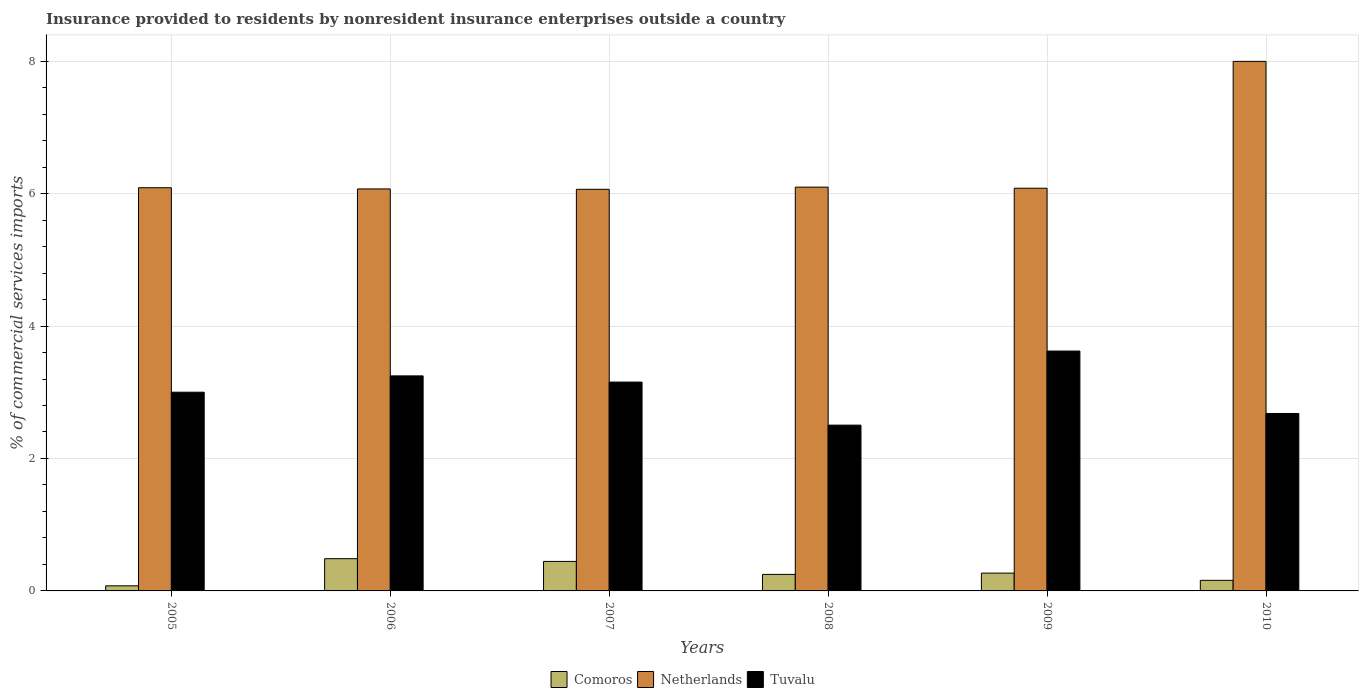How many different coloured bars are there?
Give a very brief answer. 3. Are the number of bars on each tick of the X-axis equal?
Ensure brevity in your answer.  Yes. How many bars are there on the 2nd tick from the right?
Provide a short and direct response. 3. What is the Insurance provided to residents in Netherlands in 2008?
Provide a succinct answer. 6.1. Across all years, what is the maximum Insurance provided to residents in Tuvalu?
Your answer should be very brief. 3.62. Across all years, what is the minimum Insurance provided to residents in Comoros?
Your answer should be very brief. 0.08. In which year was the Insurance provided to residents in Tuvalu maximum?
Make the answer very short. 2009. What is the total Insurance provided to residents in Comoros in the graph?
Keep it short and to the point. 1.69. What is the difference between the Insurance provided to residents in Tuvalu in 2006 and that in 2007?
Offer a very short reply. 0.09. What is the difference between the Insurance provided to residents in Netherlands in 2009 and the Insurance provided to residents in Tuvalu in 2006?
Your answer should be very brief. 2.83. What is the average Insurance provided to residents in Comoros per year?
Give a very brief answer. 0.28. In the year 2008, what is the difference between the Insurance provided to residents in Tuvalu and Insurance provided to residents in Comoros?
Make the answer very short. 2.25. In how many years, is the Insurance provided to residents in Tuvalu greater than 3.6 %?
Give a very brief answer. 1. What is the ratio of the Insurance provided to residents in Tuvalu in 2006 to that in 2009?
Your answer should be very brief. 0.9. Is the difference between the Insurance provided to residents in Tuvalu in 2009 and 2010 greater than the difference between the Insurance provided to residents in Comoros in 2009 and 2010?
Keep it short and to the point. Yes. What is the difference between the highest and the second highest Insurance provided to residents in Comoros?
Offer a terse response. 0.04. What is the difference between the highest and the lowest Insurance provided to residents in Comoros?
Offer a terse response. 0.41. In how many years, is the Insurance provided to residents in Tuvalu greater than the average Insurance provided to residents in Tuvalu taken over all years?
Give a very brief answer. 3. What does the 3rd bar from the left in 2007 represents?
Provide a succinct answer. Tuvalu. Is it the case that in every year, the sum of the Insurance provided to residents in Netherlands and Insurance provided to residents in Tuvalu is greater than the Insurance provided to residents in Comoros?
Your answer should be very brief. Yes. How many bars are there?
Make the answer very short. 18. How many years are there in the graph?
Give a very brief answer. 6. Are the values on the major ticks of Y-axis written in scientific E-notation?
Provide a short and direct response. No. Does the graph contain any zero values?
Your response must be concise. No. Does the graph contain grids?
Offer a terse response. Yes. What is the title of the graph?
Give a very brief answer. Insurance provided to residents by nonresident insurance enterprises outside a country. Does "Costa Rica" appear as one of the legend labels in the graph?
Offer a very short reply. No. What is the label or title of the Y-axis?
Provide a succinct answer. % of commercial services imports. What is the % of commercial services imports in Comoros in 2005?
Offer a very short reply. 0.08. What is the % of commercial services imports of Netherlands in 2005?
Ensure brevity in your answer.  6.09. What is the % of commercial services imports of Tuvalu in 2005?
Offer a very short reply. 3. What is the % of commercial services imports in Comoros in 2006?
Make the answer very short. 0.49. What is the % of commercial services imports of Netherlands in 2006?
Offer a terse response. 6.07. What is the % of commercial services imports in Tuvalu in 2006?
Your answer should be compact. 3.25. What is the % of commercial services imports in Comoros in 2007?
Offer a terse response. 0.45. What is the % of commercial services imports in Netherlands in 2007?
Your answer should be compact. 6.06. What is the % of commercial services imports in Tuvalu in 2007?
Make the answer very short. 3.15. What is the % of commercial services imports of Comoros in 2008?
Your answer should be compact. 0.25. What is the % of commercial services imports in Netherlands in 2008?
Your response must be concise. 6.1. What is the % of commercial services imports of Tuvalu in 2008?
Ensure brevity in your answer.  2.5. What is the % of commercial services imports in Comoros in 2009?
Provide a succinct answer. 0.27. What is the % of commercial services imports of Netherlands in 2009?
Keep it short and to the point. 6.08. What is the % of commercial services imports in Tuvalu in 2009?
Provide a short and direct response. 3.62. What is the % of commercial services imports of Comoros in 2010?
Your response must be concise. 0.16. What is the % of commercial services imports of Netherlands in 2010?
Make the answer very short. 8. What is the % of commercial services imports of Tuvalu in 2010?
Give a very brief answer. 2.68. Across all years, what is the maximum % of commercial services imports in Comoros?
Your response must be concise. 0.49. Across all years, what is the maximum % of commercial services imports of Netherlands?
Provide a short and direct response. 8. Across all years, what is the maximum % of commercial services imports in Tuvalu?
Make the answer very short. 3.62. Across all years, what is the minimum % of commercial services imports in Comoros?
Offer a terse response. 0.08. Across all years, what is the minimum % of commercial services imports in Netherlands?
Your answer should be compact. 6.06. Across all years, what is the minimum % of commercial services imports of Tuvalu?
Ensure brevity in your answer.  2.5. What is the total % of commercial services imports in Comoros in the graph?
Provide a short and direct response. 1.69. What is the total % of commercial services imports in Netherlands in the graph?
Keep it short and to the point. 38.4. What is the total % of commercial services imports of Tuvalu in the graph?
Make the answer very short. 18.21. What is the difference between the % of commercial services imports of Comoros in 2005 and that in 2006?
Ensure brevity in your answer.  -0.41. What is the difference between the % of commercial services imports in Netherlands in 2005 and that in 2006?
Offer a very short reply. 0.02. What is the difference between the % of commercial services imports in Tuvalu in 2005 and that in 2006?
Provide a short and direct response. -0.25. What is the difference between the % of commercial services imports of Comoros in 2005 and that in 2007?
Your response must be concise. -0.37. What is the difference between the % of commercial services imports in Netherlands in 2005 and that in 2007?
Give a very brief answer. 0.02. What is the difference between the % of commercial services imports of Tuvalu in 2005 and that in 2007?
Provide a short and direct response. -0.15. What is the difference between the % of commercial services imports in Comoros in 2005 and that in 2008?
Give a very brief answer. -0.17. What is the difference between the % of commercial services imports of Netherlands in 2005 and that in 2008?
Offer a very short reply. -0.01. What is the difference between the % of commercial services imports of Tuvalu in 2005 and that in 2008?
Provide a succinct answer. 0.5. What is the difference between the % of commercial services imports in Comoros in 2005 and that in 2009?
Provide a short and direct response. -0.19. What is the difference between the % of commercial services imports of Netherlands in 2005 and that in 2009?
Provide a succinct answer. 0.01. What is the difference between the % of commercial services imports in Tuvalu in 2005 and that in 2009?
Ensure brevity in your answer.  -0.62. What is the difference between the % of commercial services imports of Comoros in 2005 and that in 2010?
Make the answer very short. -0.08. What is the difference between the % of commercial services imports in Netherlands in 2005 and that in 2010?
Your answer should be compact. -1.91. What is the difference between the % of commercial services imports of Tuvalu in 2005 and that in 2010?
Provide a succinct answer. 0.32. What is the difference between the % of commercial services imports in Comoros in 2006 and that in 2007?
Your response must be concise. 0.04. What is the difference between the % of commercial services imports of Netherlands in 2006 and that in 2007?
Give a very brief answer. 0.01. What is the difference between the % of commercial services imports in Tuvalu in 2006 and that in 2007?
Provide a short and direct response. 0.09. What is the difference between the % of commercial services imports of Comoros in 2006 and that in 2008?
Your answer should be very brief. 0.24. What is the difference between the % of commercial services imports of Netherlands in 2006 and that in 2008?
Provide a short and direct response. -0.03. What is the difference between the % of commercial services imports in Tuvalu in 2006 and that in 2008?
Your response must be concise. 0.74. What is the difference between the % of commercial services imports in Comoros in 2006 and that in 2009?
Make the answer very short. 0.22. What is the difference between the % of commercial services imports of Netherlands in 2006 and that in 2009?
Ensure brevity in your answer.  -0.01. What is the difference between the % of commercial services imports in Tuvalu in 2006 and that in 2009?
Ensure brevity in your answer.  -0.38. What is the difference between the % of commercial services imports in Comoros in 2006 and that in 2010?
Provide a succinct answer. 0.33. What is the difference between the % of commercial services imports of Netherlands in 2006 and that in 2010?
Ensure brevity in your answer.  -1.93. What is the difference between the % of commercial services imports of Tuvalu in 2006 and that in 2010?
Your answer should be very brief. 0.57. What is the difference between the % of commercial services imports in Comoros in 2007 and that in 2008?
Provide a short and direct response. 0.2. What is the difference between the % of commercial services imports of Netherlands in 2007 and that in 2008?
Your response must be concise. -0.03. What is the difference between the % of commercial services imports in Tuvalu in 2007 and that in 2008?
Provide a succinct answer. 0.65. What is the difference between the % of commercial services imports in Comoros in 2007 and that in 2009?
Your answer should be compact. 0.18. What is the difference between the % of commercial services imports of Netherlands in 2007 and that in 2009?
Provide a short and direct response. -0.02. What is the difference between the % of commercial services imports in Tuvalu in 2007 and that in 2009?
Ensure brevity in your answer.  -0.47. What is the difference between the % of commercial services imports of Comoros in 2007 and that in 2010?
Make the answer very short. 0.29. What is the difference between the % of commercial services imports in Netherlands in 2007 and that in 2010?
Your response must be concise. -1.93. What is the difference between the % of commercial services imports of Tuvalu in 2007 and that in 2010?
Provide a short and direct response. 0.47. What is the difference between the % of commercial services imports in Comoros in 2008 and that in 2009?
Your answer should be very brief. -0.02. What is the difference between the % of commercial services imports in Netherlands in 2008 and that in 2009?
Keep it short and to the point. 0.02. What is the difference between the % of commercial services imports in Tuvalu in 2008 and that in 2009?
Ensure brevity in your answer.  -1.12. What is the difference between the % of commercial services imports in Comoros in 2008 and that in 2010?
Make the answer very short. 0.09. What is the difference between the % of commercial services imports of Netherlands in 2008 and that in 2010?
Keep it short and to the point. -1.9. What is the difference between the % of commercial services imports in Tuvalu in 2008 and that in 2010?
Keep it short and to the point. -0.18. What is the difference between the % of commercial services imports in Comoros in 2009 and that in 2010?
Offer a terse response. 0.11. What is the difference between the % of commercial services imports of Netherlands in 2009 and that in 2010?
Provide a short and direct response. -1.92. What is the difference between the % of commercial services imports of Tuvalu in 2009 and that in 2010?
Give a very brief answer. 0.94. What is the difference between the % of commercial services imports of Comoros in 2005 and the % of commercial services imports of Netherlands in 2006?
Ensure brevity in your answer.  -5.99. What is the difference between the % of commercial services imports of Comoros in 2005 and the % of commercial services imports of Tuvalu in 2006?
Offer a very short reply. -3.17. What is the difference between the % of commercial services imports of Netherlands in 2005 and the % of commercial services imports of Tuvalu in 2006?
Keep it short and to the point. 2.84. What is the difference between the % of commercial services imports in Comoros in 2005 and the % of commercial services imports in Netherlands in 2007?
Give a very brief answer. -5.99. What is the difference between the % of commercial services imports in Comoros in 2005 and the % of commercial services imports in Tuvalu in 2007?
Provide a short and direct response. -3.08. What is the difference between the % of commercial services imports of Netherlands in 2005 and the % of commercial services imports of Tuvalu in 2007?
Offer a very short reply. 2.93. What is the difference between the % of commercial services imports of Comoros in 2005 and the % of commercial services imports of Netherlands in 2008?
Provide a succinct answer. -6.02. What is the difference between the % of commercial services imports of Comoros in 2005 and the % of commercial services imports of Tuvalu in 2008?
Your answer should be very brief. -2.43. What is the difference between the % of commercial services imports of Netherlands in 2005 and the % of commercial services imports of Tuvalu in 2008?
Provide a short and direct response. 3.59. What is the difference between the % of commercial services imports of Comoros in 2005 and the % of commercial services imports of Netherlands in 2009?
Ensure brevity in your answer.  -6. What is the difference between the % of commercial services imports of Comoros in 2005 and the % of commercial services imports of Tuvalu in 2009?
Offer a terse response. -3.55. What is the difference between the % of commercial services imports of Netherlands in 2005 and the % of commercial services imports of Tuvalu in 2009?
Your response must be concise. 2.47. What is the difference between the % of commercial services imports of Comoros in 2005 and the % of commercial services imports of Netherlands in 2010?
Provide a short and direct response. -7.92. What is the difference between the % of commercial services imports in Comoros in 2005 and the % of commercial services imports in Tuvalu in 2010?
Your response must be concise. -2.6. What is the difference between the % of commercial services imports of Netherlands in 2005 and the % of commercial services imports of Tuvalu in 2010?
Provide a short and direct response. 3.41. What is the difference between the % of commercial services imports of Comoros in 2006 and the % of commercial services imports of Netherlands in 2007?
Offer a very short reply. -5.58. What is the difference between the % of commercial services imports in Comoros in 2006 and the % of commercial services imports in Tuvalu in 2007?
Provide a short and direct response. -2.67. What is the difference between the % of commercial services imports of Netherlands in 2006 and the % of commercial services imports of Tuvalu in 2007?
Keep it short and to the point. 2.92. What is the difference between the % of commercial services imports of Comoros in 2006 and the % of commercial services imports of Netherlands in 2008?
Ensure brevity in your answer.  -5.61. What is the difference between the % of commercial services imports of Comoros in 2006 and the % of commercial services imports of Tuvalu in 2008?
Your answer should be very brief. -2.02. What is the difference between the % of commercial services imports in Netherlands in 2006 and the % of commercial services imports in Tuvalu in 2008?
Give a very brief answer. 3.57. What is the difference between the % of commercial services imports of Comoros in 2006 and the % of commercial services imports of Netherlands in 2009?
Make the answer very short. -5.59. What is the difference between the % of commercial services imports of Comoros in 2006 and the % of commercial services imports of Tuvalu in 2009?
Give a very brief answer. -3.14. What is the difference between the % of commercial services imports in Netherlands in 2006 and the % of commercial services imports in Tuvalu in 2009?
Your answer should be very brief. 2.45. What is the difference between the % of commercial services imports in Comoros in 2006 and the % of commercial services imports in Netherlands in 2010?
Make the answer very short. -7.51. What is the difference between the % of commercial services imports in Comoros in 2006 and the % of commercial services imports in Tuvalu in 2010?
Keep it short and to the point. -2.19. What is the difference between the % of commercial services imports in Netherlands in 2006 and the % of commercial services imports in Tuvalu in 2010?
Your answer should be compact. 3.39. What is the difference between the % of commercial services imports in Comoros in 2007 and the % of commercial services imports in Netherlands in 2008?
Offer a terse response. -5.65. What is the difference between the % of commercial services imports in Comoros in 2007 and the % of commercial services imports in Tuvalu in 2008?
Ensure brevity in your answer.  -2.06. What is the difference between the % of commercial services imports of Netherlands in 2007 and the % of commercial services imports of Tuvalu in 2008?
Keep it short and to the point. 3.56. What is the difference between the % of commercial services imports of Comoros in 2007 and the % of commercial services imports of Netherlands in 2009?
Make the answer very short. -5.64. What is the difference between the % of commercial services imports in Comoros in 2007 and the % of commercial services imports in Tuvalu in 2009?
Provide a short and direct response. -3.18. What is the difference between the % of commercial services imports of Netherlands in 2007 and the % of commercial services imports of Tuvalu in 2009?
Provide a short and direct response. 2.44. What is the difference between the % of commercial services imports in Comoros in 2007 and the % of commercial services imports in Netherlands in 2010?
Your response must be concise. -7.55. What is the difference between the % of commercial services imports in Comoros in 2007 and the % of commercial services imports in Tuvalu in 2010?
Offer a terse response. -2.23. What is the difference between the % of commercial services imports of Netherlands in 2007 and the % of commercial services imports of Tuvalu in 2010?
Keep it short and to the point. 3.39. What is the difference between the % of commercial services imports in Comoros in 2008 and the % of commercial services imports in Netherlands in 2009?
Provide a short and direct response. -5.83. What is the difference between the % of commercial services imports of Comoros in 2008 and the % of commercial services imports of Tuvalu in 2009?
Ensure brevity in your answer.  -3.37. What is the difference between the % of commercial services imports of Netherlands in 2008 and the % of commercial services imports of Tuvalu in 2009?
Keep it short and to the point. 2.48. What is the difference between the % of commercial services imports of Comoros in 2008 and the % of commercial services imports of Netherlands in 2010?
Offer a terse response. -7.75. What is the difference between the % of commercial services imports in Comoros in 2008 and the % of commercial services imports in Tuvalu in 2010?
Your answer should be very brief. -2.43. What is the difference between the % of commercial services imports in Netherlands in 2008 and the % of commercial services imports in Tuvalu in 2010?
Offer a terse response. 3.42. What is the difference between the % of commercial services imports of Comoros in 2009 and the % of commercial services imports of Netherlands in 2010?
Offer a very short reply. -7.73. What is the difference between the % of commercial services imports of Comoros in 2009 and the % of commercial services imports of Tuvalu in 2010?
Your answer should be very brief. -2.41. What is the difference between the % of commercial services imports of Netherlands in 2009 and the % of commercial services imports of Tuvalu in 2010?
Your response must be concise. 3.4. What is the average % of commercial services imports of Comoros per year?
Your answer should be very brief. 0.28. What is the average % of commercial services imports in Netherlands per year?
Make the answer very short. 6.4. What is the average % of commercial services imports of Tuvalu per year?
Keep it short and to the point. 3.03. In the year 2005, what is the difference between the % of commercial services imports of Comoros and % of commercial services imports of Netherlands?
Your answer should be very brief. -6.01. In the year 2005, what is the difference between the % of commercial services imports of Comoros and % of commercial services imports of Tuvalu?
Your answer should be compact. -2.92. In the year 2005, what is the difference between the % of commercial services imports of Netherlands and % of commercial services imports of Tuvalu?
Keep it short and to the point. 3.09. In the year 2006, what is the difference between the % of commercial services imports in Comoros and % of commercial services imports in Netherlands?
Keep it short and to the point. -5.58. In the year 2006, what is the difference between the % of commercial services imports of Comoros and % of commercial services imports of Tuvalu?
Make the answer very short. -2.76. In the year 2006, what is the difference between the % of commercial services imports in Netherlands and % of commercial services imports in Tuvalu?
Make the answer very short. 2.82. In the year 2007, what is the difference between the % of commercial services imports in Comoros and % of commercial services imports in Netherlands?
Make the answer very short. -5.62. In the year 2007, what is the difference between the % of commercial services imports of Comoros and % of commercial services imports of Tuvalu?
Offer a terse response. -2.71. In the year 2007, what is the difference between the % of commercial services imports in Netherlands and % of commercial services imports in Tuvalu?
Your response must be concise. 2.91. In the year 2008, what is the difference between the % of commercial services imports in Comoros and % of commercial services imports in Netherlands?
Your answer should be compact. -5.85. In the year 2008, what is the difference between the % of commercial services imports in Comoros and % of commercial services imports in Tuvalu?
Your answer should be compact. -2.25. In the year 2008, what is the difference between the % of commercial services imports of Netherlands and % of commercial services imports of Tuvalu?
Provide a short and direct response. 3.59. In the year 2009, what is the difference between the % of commercial services imports in Comoros and % of commercial services imports in Netherlands?
Make the answer very short. -5.81. In the year 2009, what is the difference between the % of commercial services imports in Comoros and % of commercial services imports in Tuvalu?
Ensure brevity in your answer.  -3.35. In the year 2009, what is the difference between the % of commercial services imports in Netherlands and % of commercial services imports in Tuvalu?
Offer a terse response. 2.46. In the year 2010, what is the difference between the % of commercial services imports in Comoros and % of commercial services imports in Netherlands?
Your answer should be compact. -7.84. In the year 2010, what is the difference between the % of commercial services imports of Comoros and % of commercial services imports of Tuvalu?
Ensure brevity in your answer.  -2.52. In the year 2010, what is the difference between the % of commercial services imports in Netherlands and % of commercial services imports in Tuvalu?
Provide a short and direct response. 5.32. What is the ratio of the % of commercial services imports of Comoros in 2005 to that in 2006?
Your answer should be very brief. 0.16. What is the ratio of the % of commercial services imports in Netherlands in 2005 to that in 2006?
Make the answer very short. 1. What is the ratio of the % of commercial services imports in Tuvalu in 2005 to that in 2006?
Make the answer very short. 0.92. What is the ratio of the % of commercial services imports in Comoros in 2005 to that in 2007?
Your response must be concise. 0.17. What is the ratio of the % of commercial services imports of Tuvalu in 2005 to that in 2007?
Give a very brief answer. 0.95. What is the ratio of the % of commercial services imports in Comoros in 2005 to that in 2008?
Your answer should be very brief. 0.31. What is the ratio of the % of commercial services imports of Netherlands in 2005 to that in 2008?
Offer a terse response. 1. What is the ratio of the % of commercial services imports in Tuvalu in 2005 to that in 2008?
Provide a succinct answer. 1.2. What is the ratio of the % of commercial services imports of Comoros in 2005 to that in 2009?
Your response must be concise. 0.29. What is the ratio of the % of commercial services imports in Tuvalu in 2005 to that in 2009?
Ensure brevity in your answer.  0.83. What is the ratio of the % of commercial services imports in Comoros in 2005 to that in 2010?
Provide a succinct answer. 0.48. What is the ratio of the % of commercial services imports of Netherlands in 2005 to that in 2010?
Offer a very short reply. 0.76. What is the ratio of the % of commercial services imports of Tuvalu in 2005 to that in 2010?
Your answer should be very brief. 1.12. What is the ratio of the % of commercial services imports of Comoros in 2006 to that in 2007?
Ensure brevity in your answer.  1.09. What is the ratio of the % of commercial services imports in Tuvalu in 2006 to that in 2007?
Keep it short and to the point. 1.03. What is the ratio of the % of commercial services imports in Comoros in 2006 to that in 2008?
Your response must be concise. 1.95. What is the ratio of the % of commercial services imports of Netherlands in 2006 to that in 2008?
Your response must be concise. 1. What is the ratio of the % of commercial services imports of Tuvalu in 2006 to that in 2008?
Ensure brevity in your answer.  1.3. What is the ratio of the % of commercial services imports in Comoros in 2006 to that in 2009?
Your response must be concise. 1.81. What is the ratio of the % of commercial services imports of Netherlands in 2006 to that in 2009?
Your answer should be very brief. 1. What is the ratio of the % of commercial services imports in Tuvalu in 2006 to that in 2009?
Make the answer very short. 0.9. What is the ratio of the % of commercial services imports in Comoros in 2006 to that in 2010?
Offer a terse response. 3.05. What is the ratio of the % of commercial services imports of Netherlands in 2006 to that in 2010?
Your answer should be compact. 0.76. What is the ratio of the % of commercial services imports in Tuvalu in 2006 to that in 2010?
Your answer should be compact. 1.21. What is the ratio of the % of commercial services imports of Comoros in 2007 to that in 2008?
Offer a terse response. 1.79. What is the ratio of the % of commercial services imports in Tuvalu in 2007 to that in 2008?
Offer a terse response. 1.26. What is the ratio of the % of commercial services imports in Comoros in 2007 to that in 2009?
Make the answer very short. 1.66. What is the ratio of the % of commercial services imports of Netherlands in 2007 to that in 2009?
Make the answer very short. 1. What is the ratio of the % of commercial services imports in Tuvalu in 2007 to that in 2009?
Keep it short and to the point. 0.87. What is the ratio of the % of commercial services imports in Comoros in 2007 to that in 2010?
Provide a succinct answer. 2.79. What is the ratio of the % of commercial services imports in Netherlands in 2007 to that in 2010?
Make the answer very short. 0.76. What is the ratio of the % of commercial services imports in Tuvalu in 2007 to that in 2010?
Keep it short and to the point. 1.18. What is the ratio of the % of commercial services imports in Comoros in 2008 to that in 2009?
Ensure brevity in your answer.  0.93. What is the ratio of the % of commercial services imports in Tuvalu in 2008 to that in 2009?
Offer a very short reply. 0.69. What is the ratio of the % of commercial services imports of Comoros in 2008 to that in 2010?
Make the answer very short. 1.56. What is the ratio of the % of commercial services imports in Netherlands in 2008 to that in 2010?
Your answer should be very brief. 0.76. What is the ratio of the % of commercial services imports in Tuvalu in 2008 to that in 2010?
Your answer should be compact. 0.93. What is the ratio of the % of commercial services imports in Comoros in 2009 to that in 2010?
Ensure brevity in your answer.  1.68. What is the ratio of the % of commercial services imports in Netherlands in 2009 to that in 2010?
Provide a succinct answer. 0.76. What is the ratio of the % of commercial services imports of Tuvalu in 2009 to that in 2010?
Your answer should be very brief. 1.35. What is the difference between the highest and the second highest % of commercial services imports in Comoros?
Ensure brevity in your answer.  0.04. What is the difference between the highest and the second highest % of commercial services imports in Netherlands?
Your answer should be compact. 1.9. What is the difference between the highest and the second highest % of commercial services imports in Tuvalu?
Provide a succinct answer. 0.38. What is the difference between the highest and the lowest % of commercial services imports in Comoros?
Offer a very short reply. 0.41. What is the difference between the highest and the lowest % of commercial services imports of Netherlands?
Your answer should be compact. 1.93. What is the difference between the highest and the lowest % of commercial services imports of Tuvalu?
Offer a terse response. 1.12. 